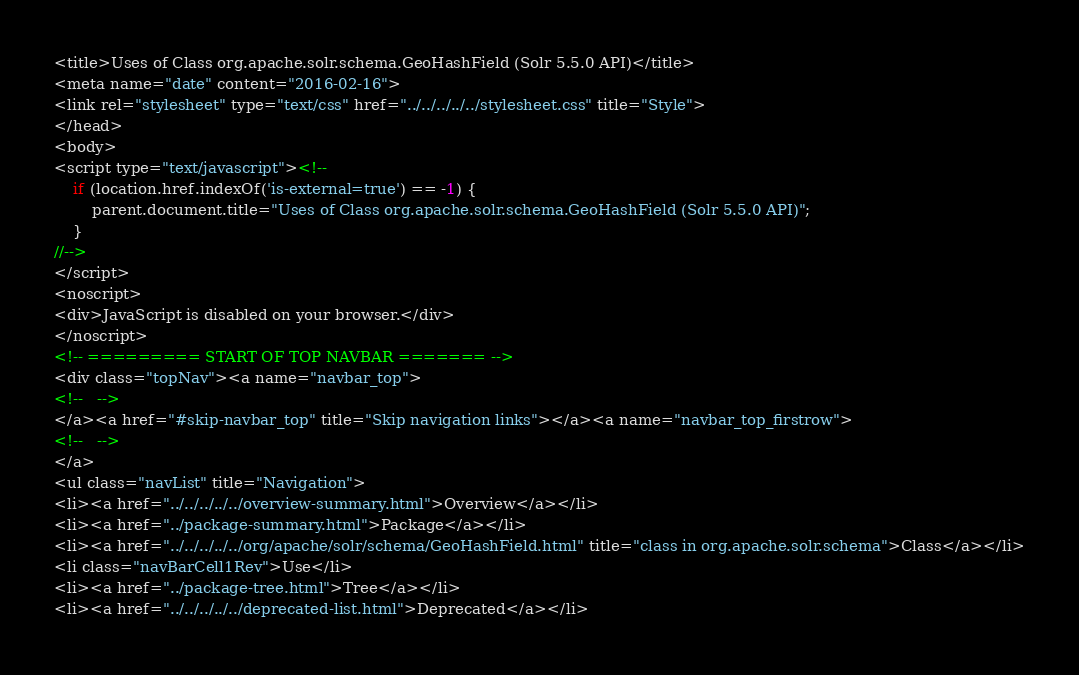<code> <loc_0><loc_0><loc_500><loc_500><_HTML_><title>Uses of Class org.apache.solr.schema.GeoHashField (Solr 5.5.0 API)</title>
<meta name="date" content="2016-02-16">
<link rel="stylesheet" type="text/css" href="../../../../../stylesheet.css" title="Style">
</head>
<body>
<script type="text/javascript"><!--
    if (location.href.indexOf('is-external=true') == -1) {
        parent.document.title="Uses of Class org.apache.solr.schema.GeoHashField (Solr 5.5.0 API)";
    }
//-->
</script>
<noscript>
<div>JavaScript is disabled on your browser.</div>
</noscript>
<!-- ========= START OF TOP NAVBAR ======= -->
<div class="topNav"><a name="navbar_top">
<!--   -->
</a><a href="#skip-navbar_top" title="Skip navigation links"></a><a name="navbar_top_firstrow">
<!--   -->
</a>
<ul class="navList" title="Navigation">
<li><a href="../../../../../overview-summary.html">Overview</a></li>
<li><a href="../package-summary.html">Package</a></li>
<li><a href="../../../../../org/apache/solr/schema/GeoHashField.html" title="class in org.apache.solr.schema">Class</a></li>
<li class="navBarCell1Rev">Use</li>
<li><a href="../package-tree.html">Tree</a></li>
<li><a href="../../../../../deprecated-list.html">Deprecated</a></li></code> 